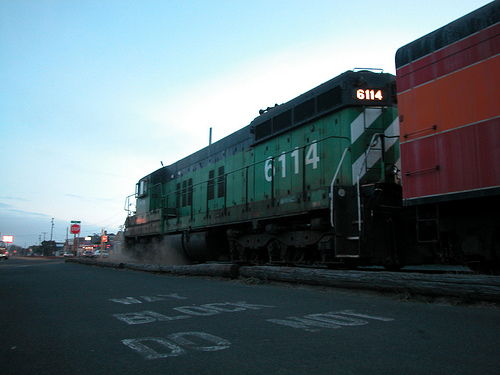Describe the overall scene captured in the image. The image captures a green train moving along tracks, with signs of an urban environment in the background. The paved road in front of the train has some markings, including 'DO NOT BLOCK'. The sky appears to be clear and the image may have been taken during early morning or late evening due to the lighting conditions. Can you tell what time of day it could likely be and why? Based on the lighting and the shadows seen in the image, it is likely either early morning or late evening. The sky has a soft, slightly dim light, suggesting the sun is not fully overhead. This kind of lighting is typical during sunrise or sunset when the sun is closer to the horizon, casting longer shadows and providing a softer illumination. 